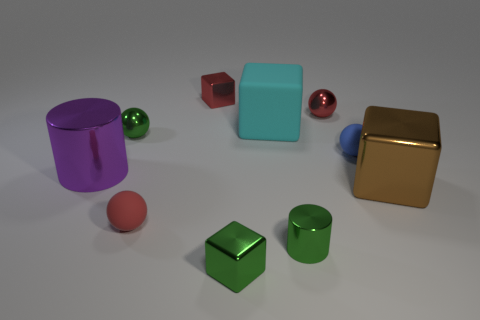Subtract all cylinders. How many objects are left? 8 Add 8 cyan blocks. How many cyan blocks exist? 9 Subtract 0 cyan spheres. How many objects are left? 10 Subtract all cyan rubber cubes. Subtract all small cylinders. How many objects are left? 8 Add 5 tiny metal spheres. How many tiny metal spheres are left? 7 